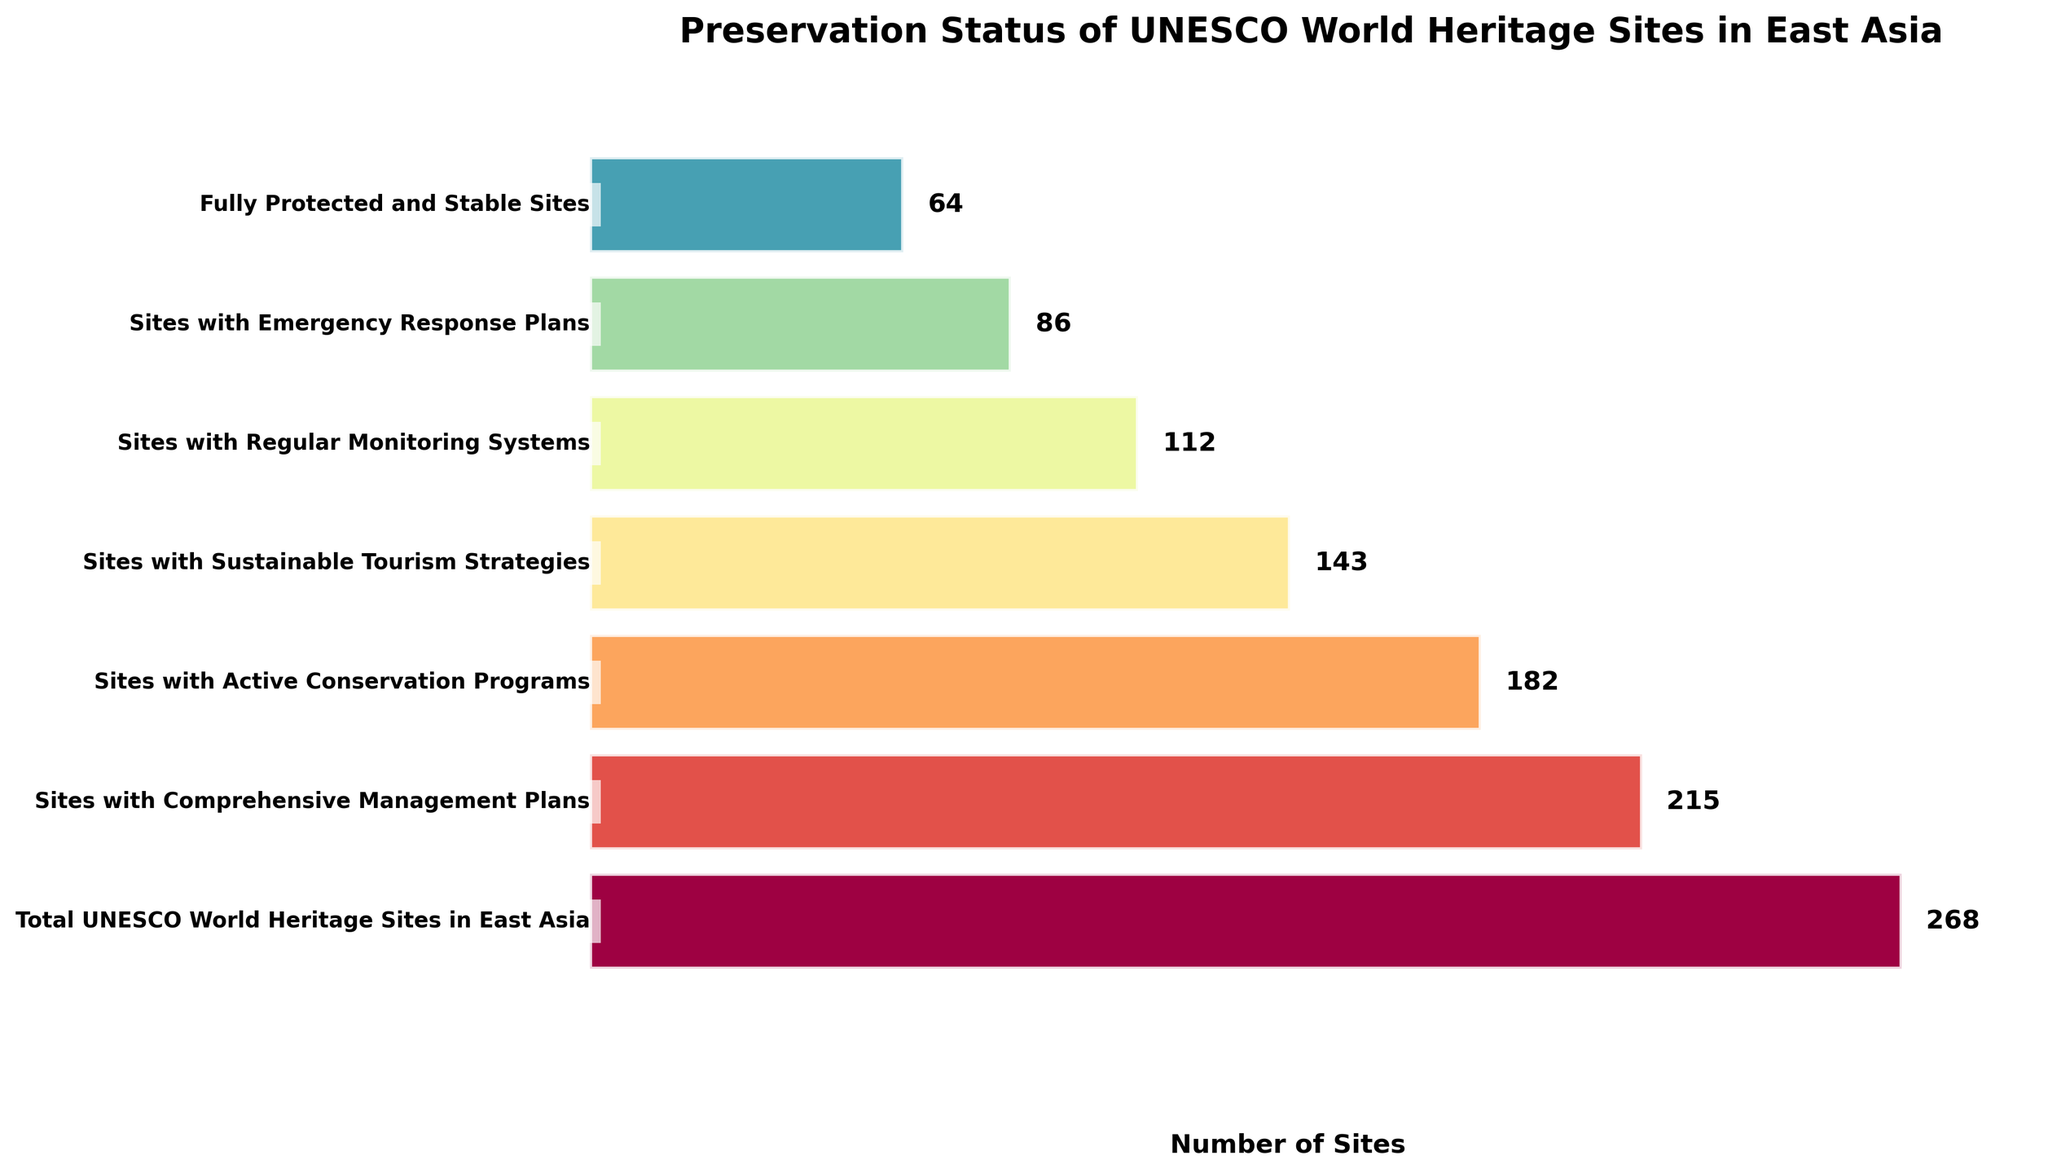What's the total number of UNESCO World Heritage Sites in East Asia? The total number is displayed at the top of the funnel chart as 268.
Answer: 268 How many sites have Comprehensive Management Plans? Refer to the second stage of the funnel chart, which shows the number of sites with Comprehensive Management Plans as 215.
Answer: 215 What is the difference between the number of sites with Active Conservation Programs and those with Sustainable Tourism Strategies? Subtract the number of sites with Sustainable Tourism Strategies (143) from the number of sites with Active Conservation Programs (182). 182 - 143 = 39.
Answer: 39 Which stage has the smallest number of sites? The bottom stage of the funnel chart represents the smallest number, which is 64 for Fully Protected and Stable Sites.
Answer: Fully Protected and Stable Sites What proportion of the total UNESCO World Heritage Sites have Regular Monitoring Systems? Divide the number of sites with Regular Monitoring Systems (112) by the total number of sites (268) and multiply by 100 to get the percentage. (112/268) * 100 ≈ 41.79%.
Answer: Approximately 41.79% Are there more sites with Regular Monitoring Systems or Emergency Response Plans? Compare the two numbers: Regular Monitoring Systems (112) and Emergency Response Plans (86). 112 is greater than 86.
Answer: Regular Monitoring Systems What is the percentage decrease in the number of sites from those with Comprehensive Management Plans to those with Active Conservation Programs? First, find the difference: 215 - 182 = 33. Then, divide by the number of sites with Comprehensive Management Plans: (33/215) * 100 ≈ 15.35%.
Answer: Approximately 15.35% How many more sites have Sustainable Tourism Strategies compared to those with Emergency Response Plans? Subtract the number of sites with Emergency Response Plans (86) from those with Sustainable Tourism Strategies (143). 143 - 86 = 57.
Answer: 57 What's the title of the chart? The title is displayed at the top of the chart: "Preservation Status of UNESCO World Heritage Sites in East Asia".
Answer: Preservation Status of UNESCO World Heritage Sites in East Asia 